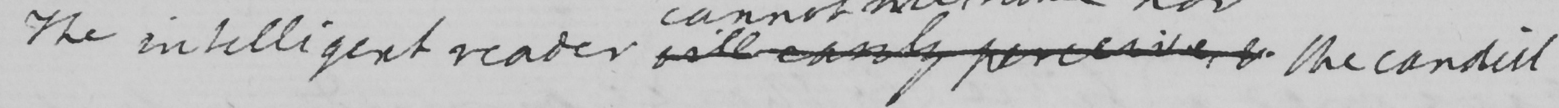Can you tell me what this handwritten text says? The intelligent reader will easily perceive & the candid 